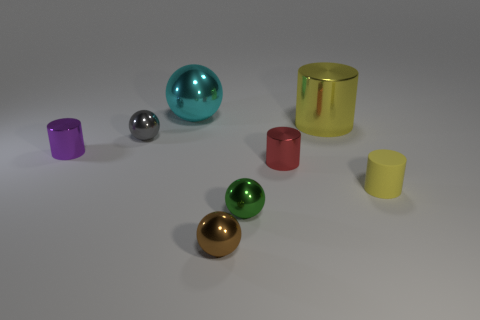Is there any other thing that is the same color as the rubber object?
Make the answer very short. Yes. Do the large metallic thing on the right side of the small brown ball and the rubber cylinder have the same color?
Offer a very short reply. Yes. What shape is the tiny object that is the same color as the large cylinder?
Offer a very short reply. Cylinder. Is there a object that has the same color as the rubber cylinder?
Your answer should be very brief. Yes. There is a cylinder that is the same color as the matte object; what is its size?
Offer a very short reply. Large. Do the tiny matte cylinder and the big metal thing that is right of the small brown object have the same color?
Offer a terse response. Yes. Is the number of tiny things right of the tiny yellow matte cylinder less than the number of large metal things on the left side of the brown shiny ball?
Keep it short and to the point. Yes. There is a thing that is both behind the small purple cylinder and to the left of the large cyan shiny ball; what is its color?
Give a very brief answer. Gray. There is a purple shiny cylinder; does it have the same size as the metal cylinder that is in front of the purple shiny cylinder?
Make the answer very short. Yes. What shape is the big metallic thing on the left side of the brown ball?
Your answer should be very brief. Sphere. 